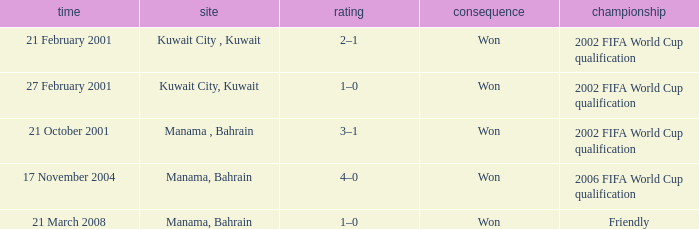What was the final score of the Friendly Competition in Manama, Bahrain? 1–0. 